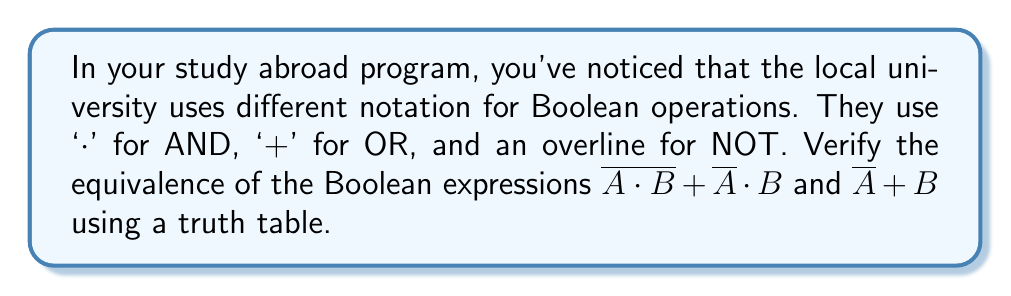Can you solve this math problem? Let's approach this step-by-step:

1) First, we'll create a truth table with columns for A, B, and each subexpression.

2) The truth table will have 4 rows (2^2) to cover all possible combinations of A and B.

3) Let's evaluate each subexpression:

   a) $\overline{A \cdot B}$
   b) $\overline{A}$
   c) $\overline{A} \cdot B$
   d) $\overline{A \cdot B} + \overline{A} \cdot B$ (Expression 1)
   e) $\overline{A} + B$ (Expression 2)

4) Here's the completed truth table:

   $$
   \begin{array}{|c|c|c|c|c|c|c|c|}
   \hline
   A & B & A \cdot B & \overline{A \cdot B} & \overline{A} & \overline{A} \cdot B & \text{Expr 1} & \text{Expr 2} \\
   \hline
   0 & 0 & 0 & 1 & 1 & 0 & 1 & 1 \\
   0 & 1 & 0 & 1 & 1 & 1 & 1 & 1 \\
   1 & 0 & 0 & 1 & 0 & 0 & 1 & 0 \\
   1 & 1 & 1 & 0 & 0 & 0 & 0 & 1 \\
   \hline
   \end{array}
   $$

5) Comparing the last two columns, we can see that they are not identical. Therefore, the expressions are not equivalent.

6) The expressions differ in the case where A = 1 and B = 0, and where A = 1 and B = 1.
Answer: Not equivalent 